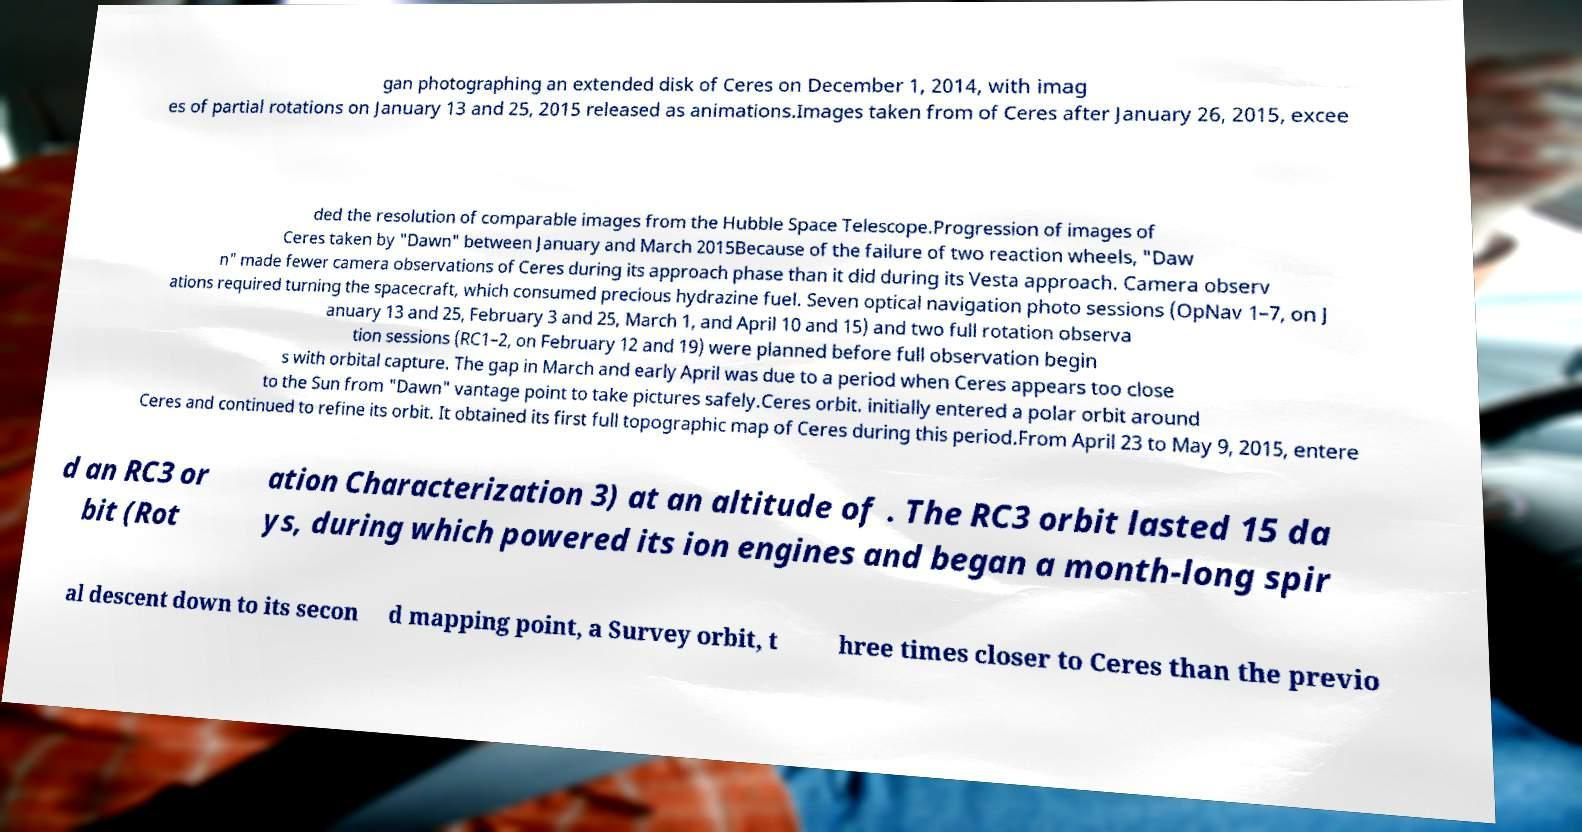There's text embedded in this image that I need extracted. Can you transcribe it verbatim? gan photographing an extended disk of Ceres on December 1, 2014, with imag es of partial rotations on January 13 and 25, 2015 released as animations.Images taken from of Ceres after January 26, 2015, excee ded the resolution of comparable images from the Hubble Space Telescope.Progression of images of Ceres taken by "Dawn" between January and March 2015Because of the failure of two reaction wheels, "Daw n" made fewer camera observations of Ceres during its approach phase than it did during its Vesta approach. Camera observ ations required turning the spacecraft, which consumed precious hydrazine fuel. Seven optical navigation photo sessions (OpNav 1–7, on J anuary 13 and 25, February 3 and 25, March 1, and April 10 and 15) and two full rotation observa tion sessions (RC1–2, on February 12 and 19) were planned before full observation begin s with orbital capture. The gap in March and early April was due to a period when Ceres appears too close to the Sun from "Dawn" vantage point to take pictures safely.Ceres orbit. initially entered a polar orbit around Ceres and continued to refine its orbit. It obtained its first full topographic map of Ceres during this period.From April 23 to May 9, 2015, entere d an RC3 or bit (Rot ation Characterization 3) at an altitude of . The RC3 orbit lasted 15 da ys, during which powered its ion engines and began a month-long spir al descent down to its secon d mapping point, a Survey orbit, t hree times closer to Ceres than the previo 